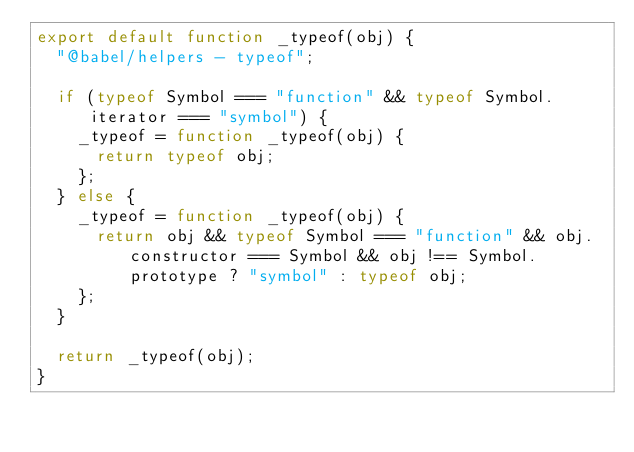<code> <loc_0><loc_0><loc_500><loc_500><_JavaScript_>export default function _typeof(obj) {
  "@babel/helpers - typeof";

  if (typeof Symbol === "function" && typeof Symbol.iterator === "symbol") {
    _typeof = function _typeof(obj) {
      return typeof obj;
    };
  } else {
    _typeof = function _typeof(obj) {
      return obj && typeof Symbol === "function" && obj.constructor === Symbol && obj !== Symbol.prototype ? "symbol" : typeof obj;
    };
  }

  return _typeof(obj);
}</code> 